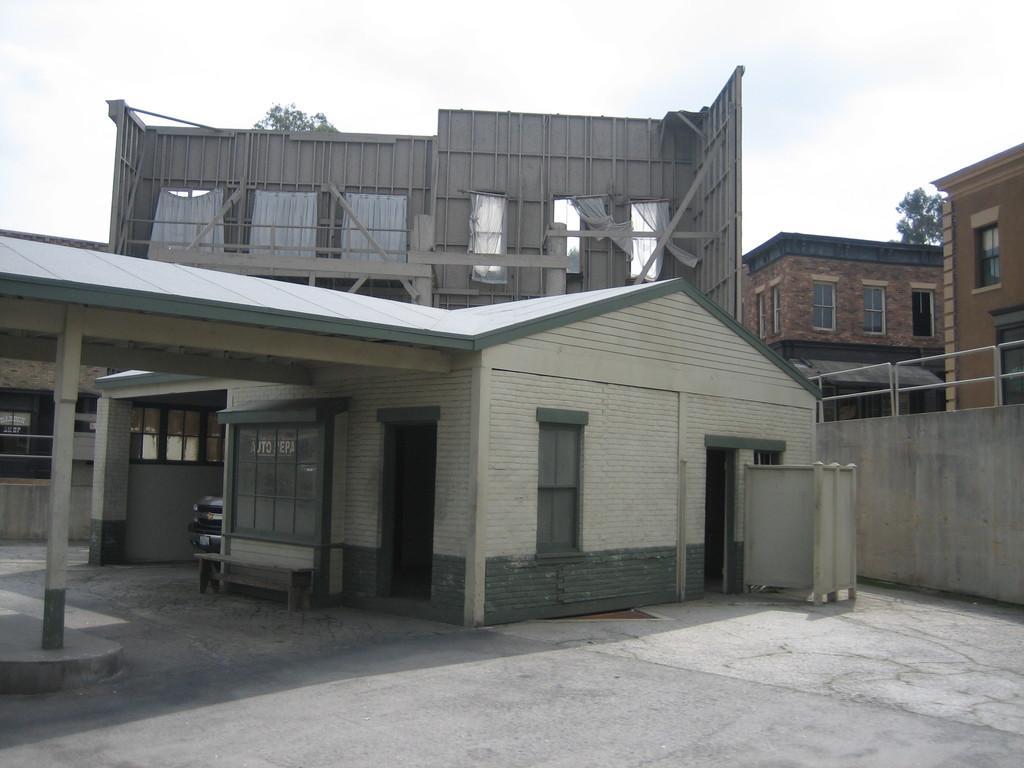In one or two sentences, can you explain what this image depicts? In this picture I can see the path in front and in the middle of this picture I see number of buildings. On the right side of this picture I see the wall. In the background I see the trees and the sky. 